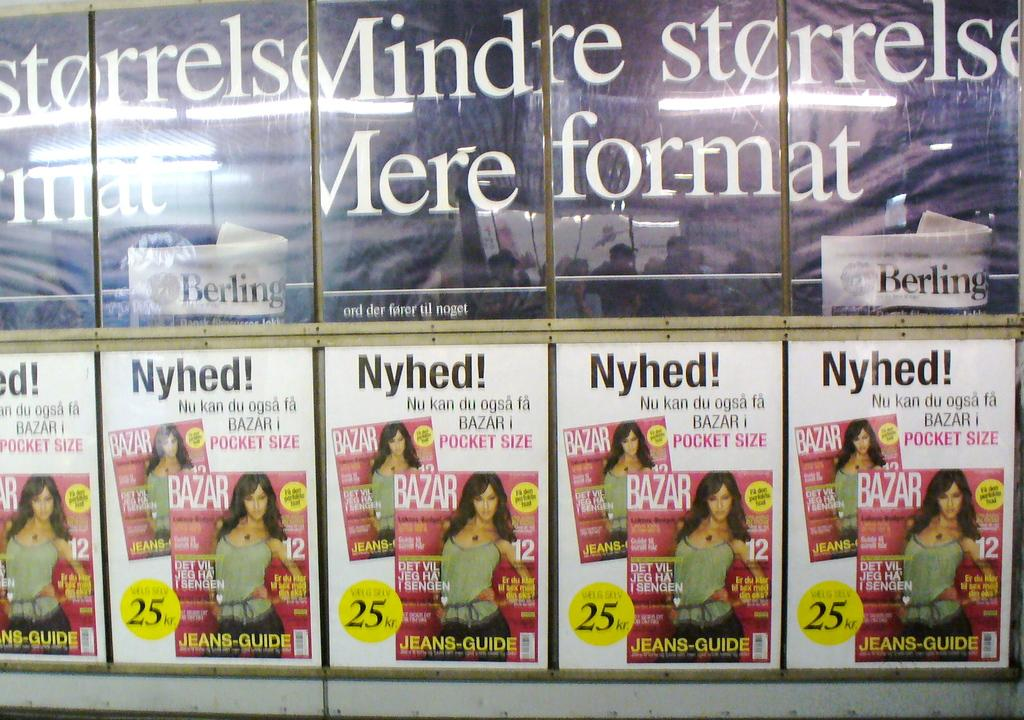<image>
Describe the image concisely. A wall display includes a promotion for Bazar Magazine at a discount. 